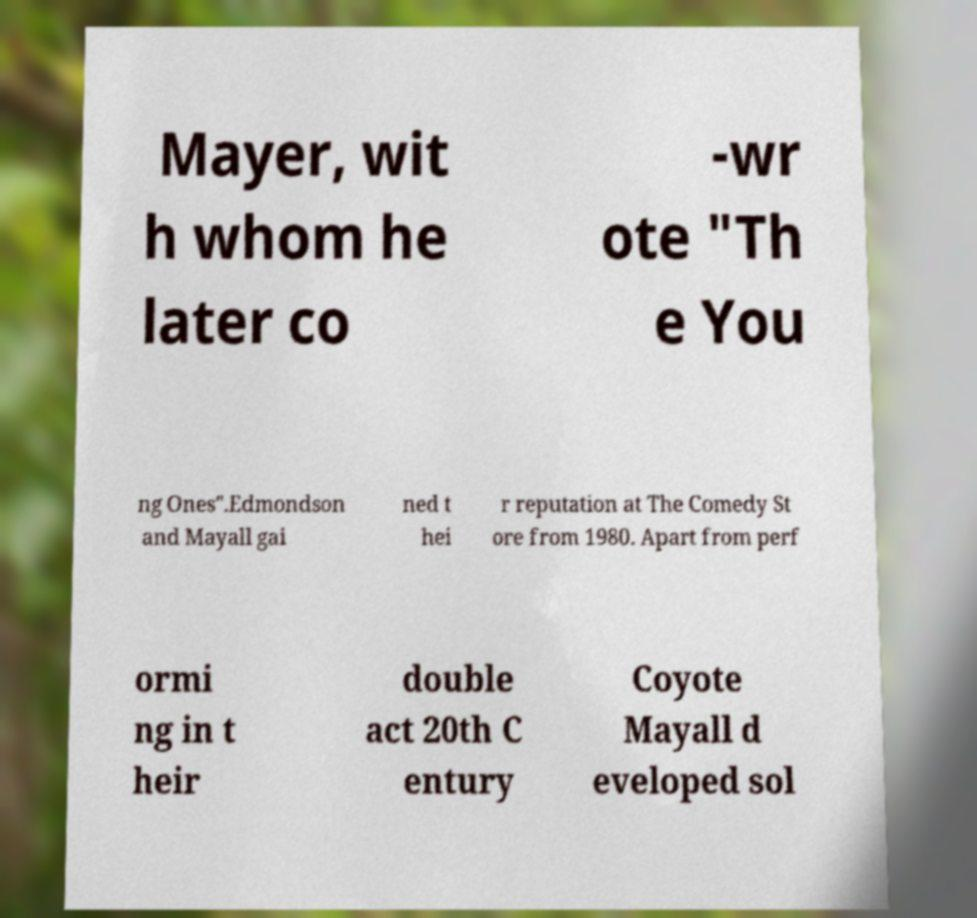Can you accurately transcribe the text from the provided image for me? Mayer, wit h whom he later co -wr ote "Th e You ng Ones".Edmondson and Mayall gai ned t hei r reputation at The Comedy St ore from 1980. Apart from perf ormi ng in t heir double act 20th C entury Coyote Mayall d eveloped sol 